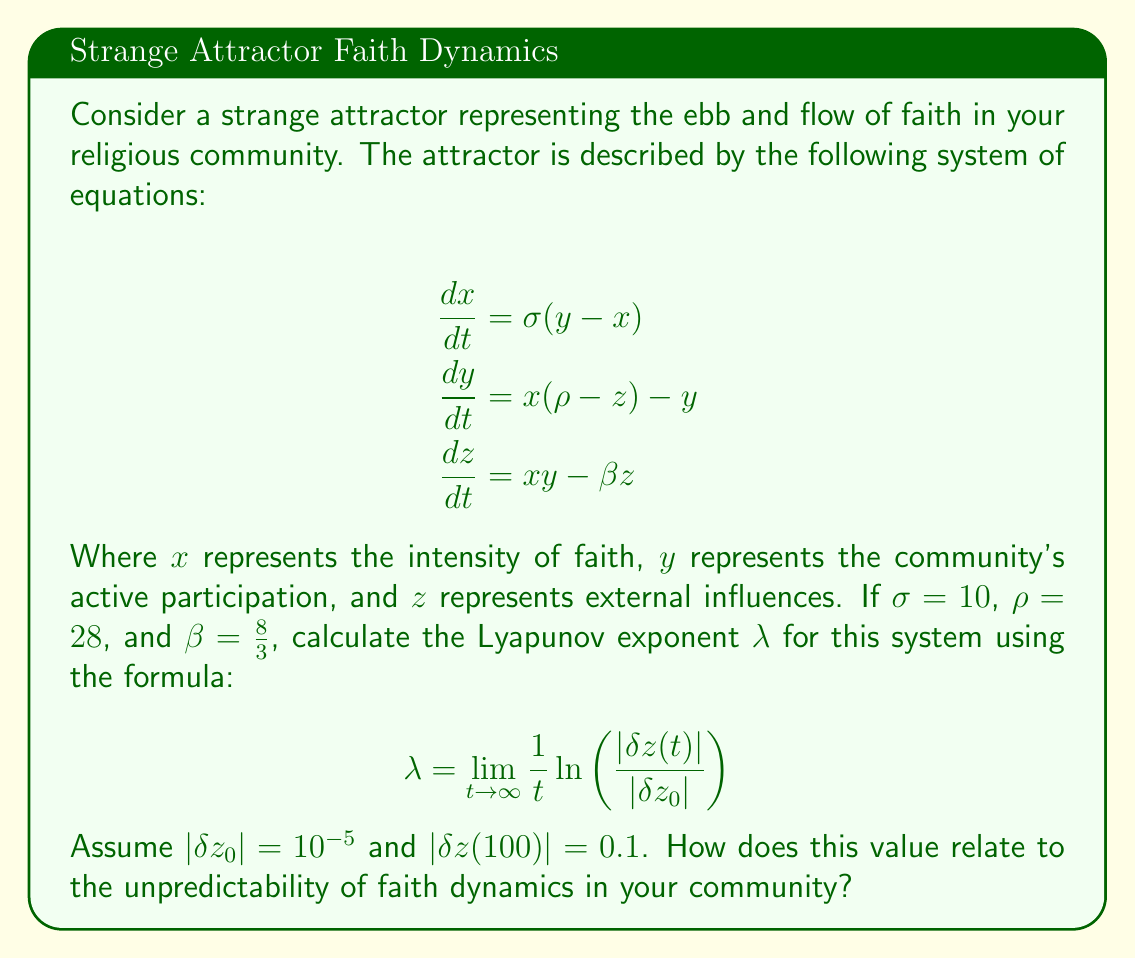Provide a solution to this math problem. To solve this problem, we'll follow these steps:

1) The given formula for the Lyapunov exponent is:

   $$\lambda = \lim_{t \to \infty} \frac{1}{t} \ln \left(\frac{|\delta z(t)|}{|\delta z_0|}\right)$$

2) We're given the following values:
   - $t = 100$
   - $|\delta z_0| = 10^{-5}$
   - $|\delta z(100)| = 0.1$

3) Let's substitute these values into the formula:

   $$\lambda \approx \frac{1}{100} \ln \left(\frac{0.1}{10^{-5}}\right)$$

4) Simplify inside the logarithm:

   $$\lambda \approx \frac{1}{100} \ln (10^4)$$

5) Use the logarithm property $\ln(a^b) = b\ln(a)$:

   $$\lambda \approx \frac{1}{100} (4 \ln(10))$$

6) Calculate:
   
   $$\lambda \approx \frac{4 \ln(10)}{100} \approx 0.0921$$

7) Interpretation: A positive Lyapunov exponent indicates chaos in the system. The value of approximately 0.0921 suggests that the faith dynamics in the community are chaotic and highly sensitive to initial conditions. This means that small changes in the initial state of the system can lead to significantly different outcomes over time, making long-term predictions of faith trends in the community very difficult.
Answer: $\lambda \approx 0.0921$, indicating chaotic faith dynamics. 